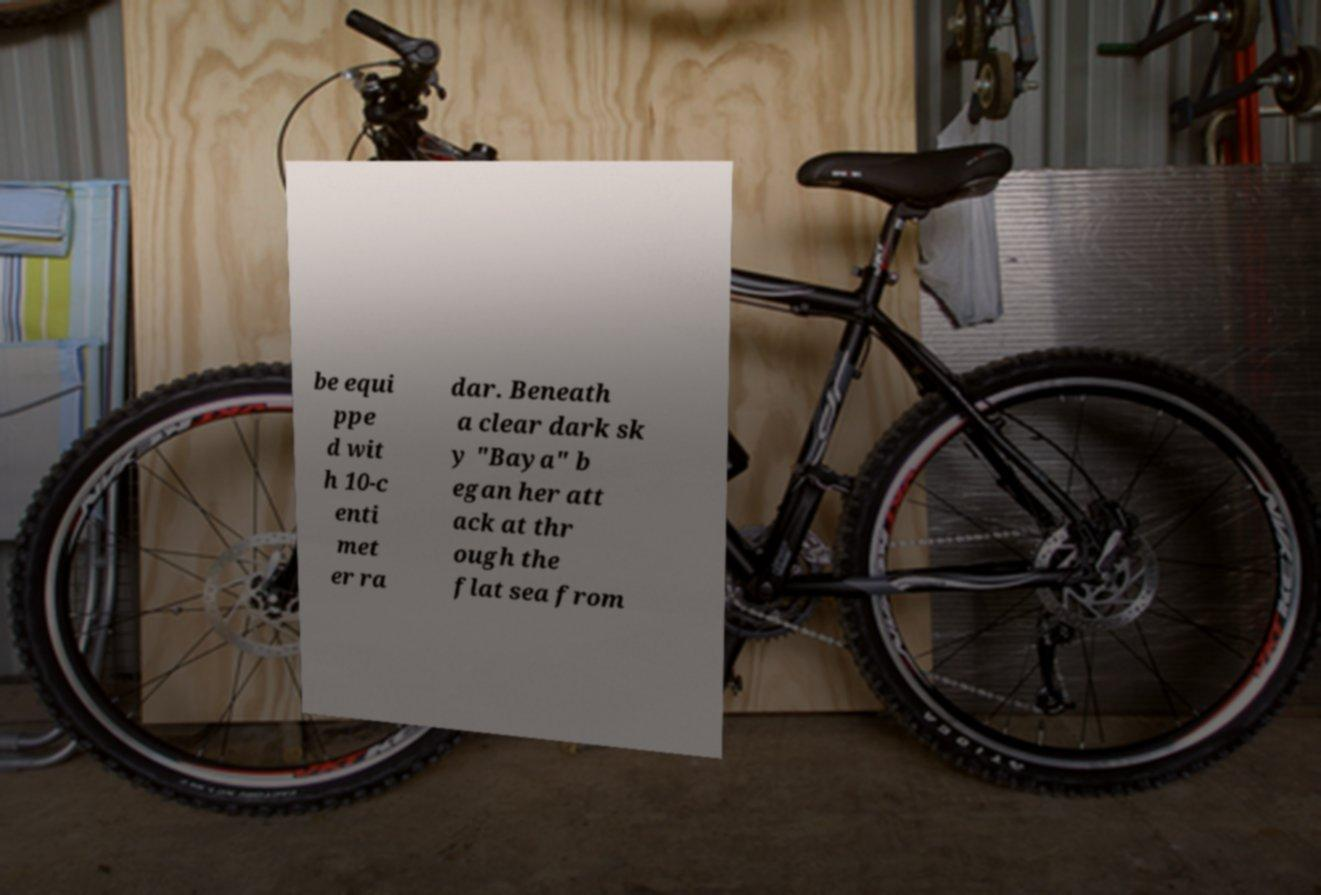What messages or text are displayed in this image? I need them in a readable, typed format. be equi ppe d wit h 10-c enti met er ra dar. Beneath a clear dark sk y "Baya" b egan her att ack at thr ough the flat sea from 